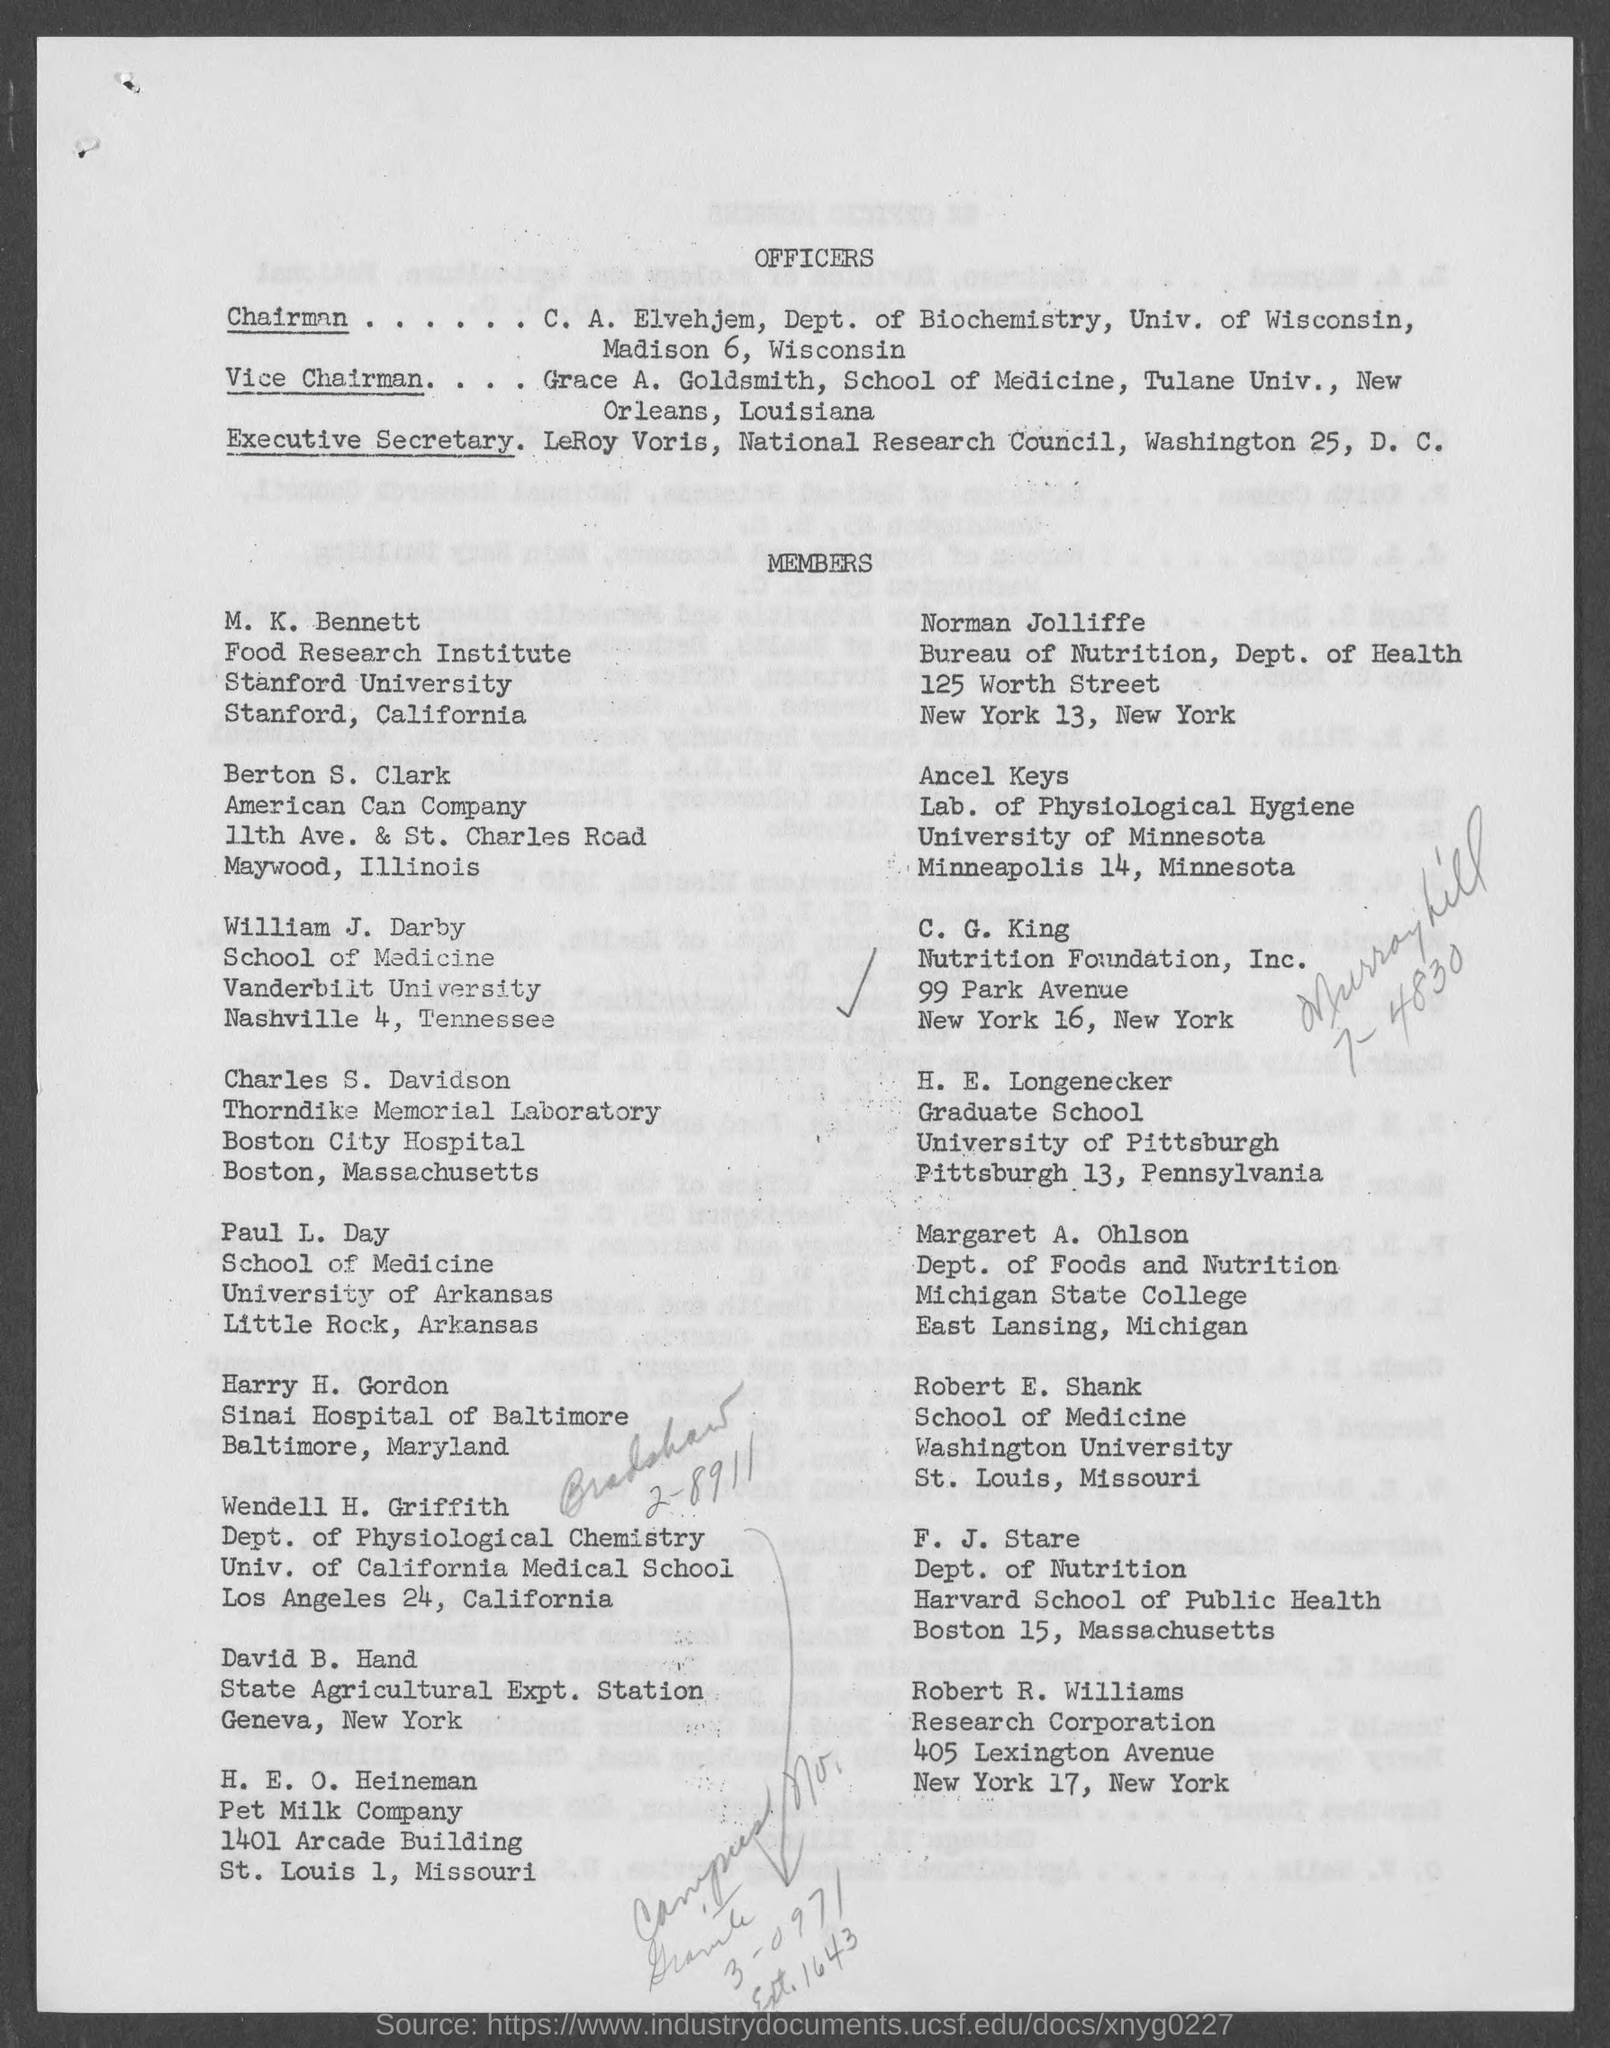Highlight a few significant elements in this photo. The name of the vice chairman mentioned in the given page is Grace A. Goldsmith. F.J. Stare belongs to the department of nutrition. William J. Darby is a student who belongs to Vanderbilt University. Berton S. Clerk is a member of the American Can Company. Leroy Voris is designated as the Executive Secretary, as mentioned on the given page. 